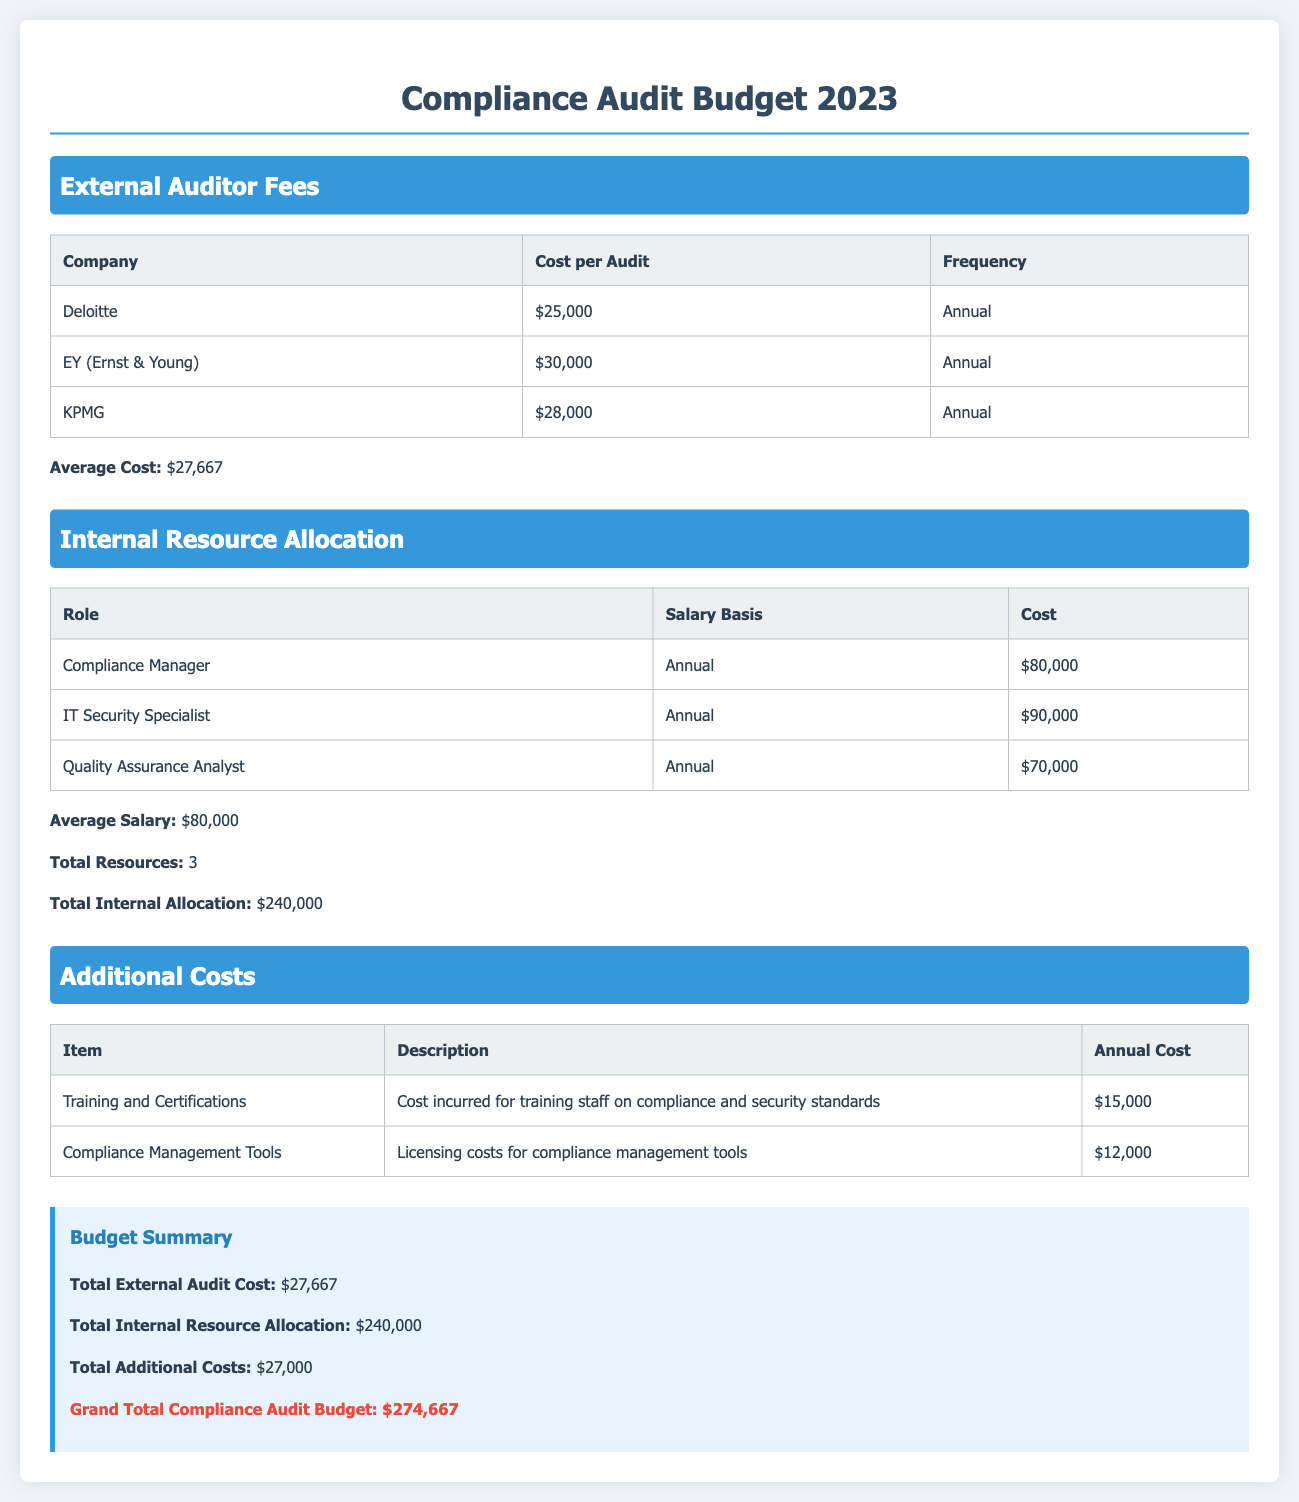What is the total external audit cost? The total external audit cost is listed in the budget summary section of the document as $27,667.
Answer: $27,667 How many roles are allocated for internal resources? The number of roles is mentioned in the Internal Resource Allocation section as 3.
Answer: 3 What is the cost for Deloitte's audit? The cost for Deloitte's audit is specified in the External Auditor Fees section as $25,000.
Answer: $25,000 What is the salary of the IT Security Specialist? The salary of the IT Security Specialist is indicated in the Internal Resource Allocation section as $90,000.
Answer: $90,000 What is the annual cost for training and certifications? The annual cost for training and certifications is detailed in the Additional Costs section as $15,000.
Answer: $15,000 What is the grand total compliance audit budget? The grand total compliance audit budget is found in the budget summary section and is calculated to be $274,667.
Answer: $274,667 Which company has the highest audit cost? The company with the highest audit cost is identified in the External Auditor Fees section as EY (Ernst & Young) with a cost of $30,000.
Answer: EY (Ernst & Young) What is the average salary of the internal resources? The average salary of the internal resources is mentioned in the Internal Resource Allocation section as $80,000.
Answer: $80,000 What is included in the additional costs? The additional costs section specifies training and certifications, and compliance management tools as included costs.
Answer: Training and Certifications, Compliance Management Tools 